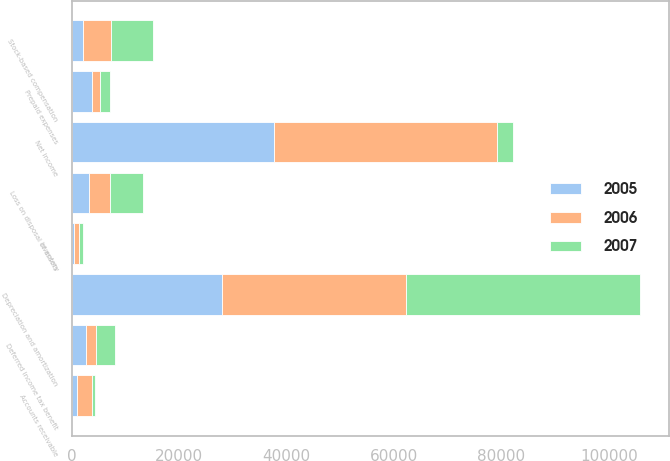<chart> <loc_0><loc_0><loc_500><loc_500><stacked_bar_chart><ecel><fcel>Net income<fcel>Depreciation and amortization<fcel>Deferred income tax benefit<fcel>Loss on disposal of assets<fcel>Stock-based compensation<fcel>Accounts receivable<fcel>Inventory<fcel>Prepaid expenses<nl><fcel>2007<fcel>3119<fcel>43595<fcel>3545<fcel>6168<fcel>7801<fcel>508<fcel>771<fcel>1885<nl><fcel>2006<fcel>41423<fcel>34253<fcel>1857<fcel>3982<fcel>5193<fcel>2873<fcel>880<fcel>1499<nl><fcel>2005<fcel>37696<fcel>28026<fcel>2654<fcel>3119<fcel>2103<fcel>916<fcel>369<fcel>3757<nl></chart> 